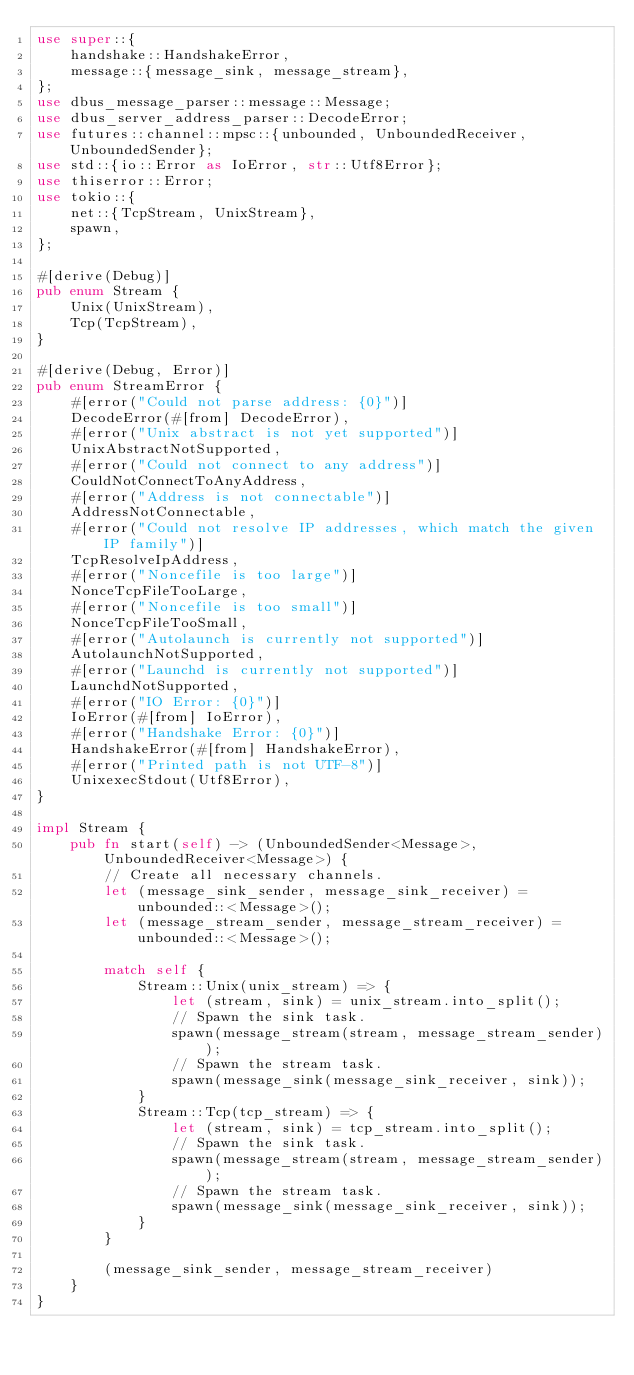<code> <loc_0><loc_0><loc_500><loc_500><_Rust_>use super::{
    handshake::HandshakeError,
    message::{message_sink, message_stream},
};
use dbus_message_parser::message::Message;
use dbus_server_address_parser::DecodeError;
use futures::channel::mpsc::{unbounded, UnboundedReceiver, UnboundedSender};
use std::{io::Error as IoError, str::Utf8Error};
use thiserror::Error;
use tokio::{
    net::{TcpStream, UnixStream},
    spawn,
};

#[derive(Debug)]
pub enum Stream {
    Unix(UnixStream),
    Tcp(TcpStream),
}

#[derive(Debug, Error)]
pub enum StreamError {
    #[error("Could not parse address: {0}")]
    DecodeError(#[from] DecodeError),
    #[error("Unix abstract is not yet supported")]
    UnixAbstractNotSupported,
    #[error("Could not connect to any address")]
    CouldNotConnectToAnyAddress,
    #[error("Address is not connectable")]
    AddressNotConnectable,
    #[error("Could not resolve IP addresses, which match the given IP family")]
    TcpResolveIpAddress,
    #[error("Noncefile is too large")]
    NonceTcpFileTooLarge,
    #[error("Noncefile is too small")]
    NonceTcpFileTooSmall,
    #[error("Autolaunch is currently not supported")]
    AutolaunchNotSupported,
    #[error("Launchd is currently not supported")]
    LaunchdNotSupported,
    #[error("IO Error: {0}")]
    IoError(#[from] IoError),
    #[error("Handshake Error: {0}")]
    HandshakeError(#[from] HandshakeError),
    #[error("Printed path is not UTF-8")]
    UnixexecStdout(Utf8Error),
}

impl Stream {
    pub fn start(self) -> (UnboundedSender<Message>, UnboundedReceiver<Message>) {
        // Create all necessary channels.
        let (message_sink_sender, message_sink_receiver) = unbounded::<Message>();
        let (message_stream_sender, message_stream_receiver) = unbounded::<Message>();

        match self {
            Stream::Unix(unix_stream) => {
                let (stream, sink) = unix_stream.into_split();
                // Spawn the sink task.
                spawn(message_stream(stream, message_stream_sender));
                // Spawn the stream task.
                spawn(message_sink(message_sink_receiver, sink));
            }
            Stream::Tcp(tcp_stream) => {
                let (stream, sink) = tcp_stream.into_split();
                // Spawn the sink task.
                spawn(message_stream(stream, message_stream_sender));
                // Spawn the stream task.
                spawn(message_sink(message_sink_receiver, sink));
            }
        }

        (message_sink_sender, message_stream_receiver)
    }
}
</code> 